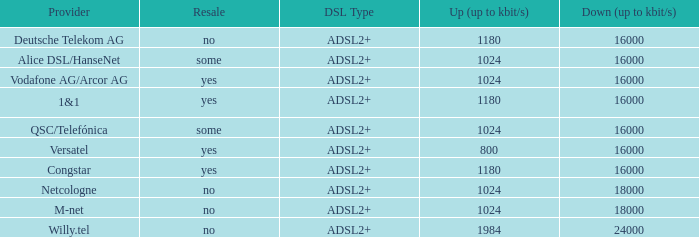What are all the dsl type offered by the M-Net telecom company? ADSL2+. 